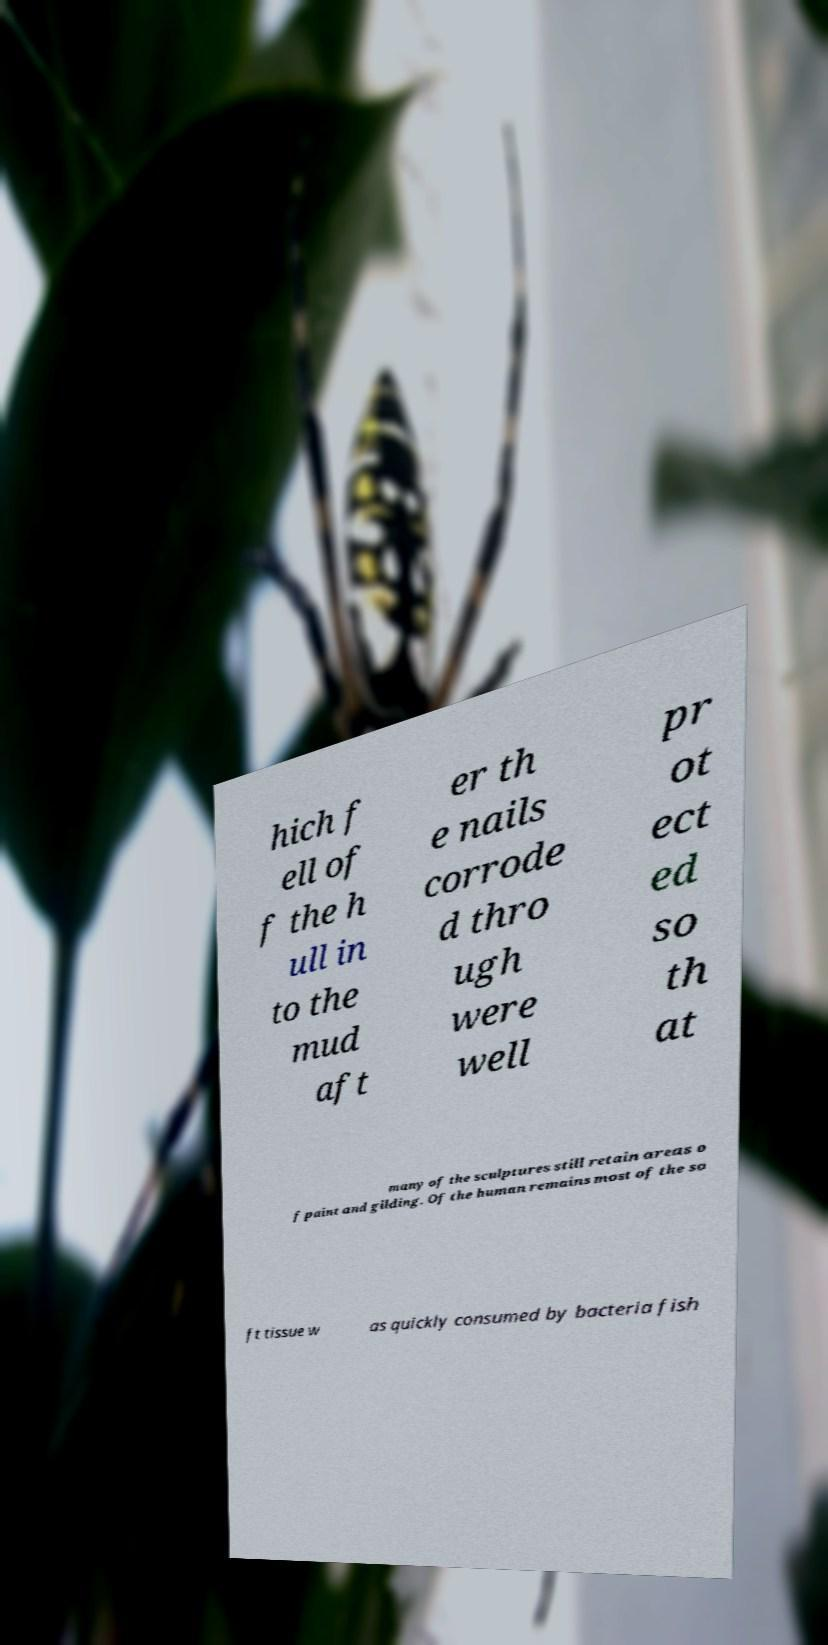Can you read and provide the text displayed in the image?This photo seems to have some interesting text. Can you extract and type it out for me? hich f ell of f the h ull in to the mud aft er th e nails corrode d thro ugh were well pr ot ect ed so th at many of the sculptures still retain areas o f paint and gilding. Of the human remains most of the so ft tissue w as quickly consumed by bacteria fish 